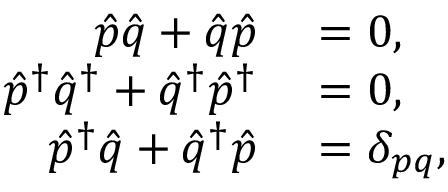<formula> <loc_0><loc_0><loc_500><loc_500>\begin{array} { r l } { \hat { p } \hat { q } + \hat { q } \hat { p } } & = 0 , } \\ { \hat { p } ^ { \dag } \hat { q } ^ { \dag } + \hat { q } ^ { \dag } \hat { p } ^ { \dag } } & = 0 , } \\ { \hat { p } ^ { \dag } \hat { q } + \hat { q } ^ { \dag } \hat { p } } & = \delta _ { p q } , } \end{array}</formula> 